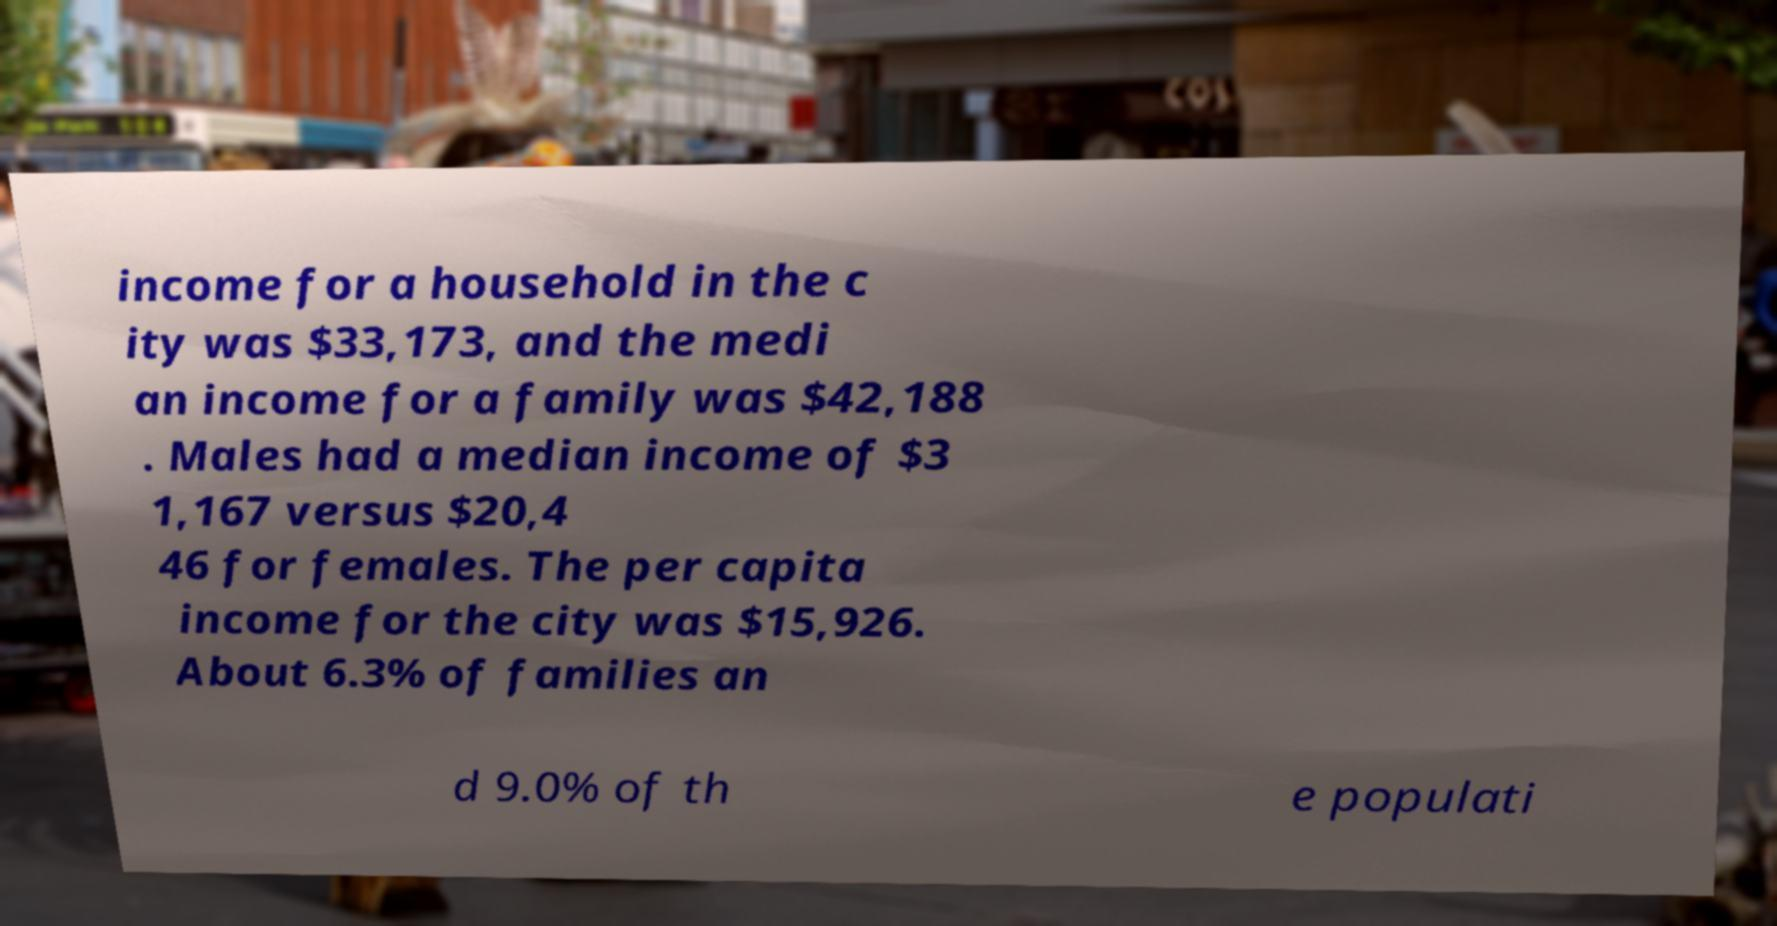What messages or text are displayed in this image? I need them in a readable, typed format. income for a household in the c ity was $33,173, and the medi an income for a family was $42,188 . Males had a median income of $3 1,167 versus $20,4 46 for females. The per capita income for the city was $15,926. About 6.3% of families an d 9.0% of th e populati 